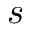<formula> <loc_0><loc_0><loc_500><loc_500>s</formula> 